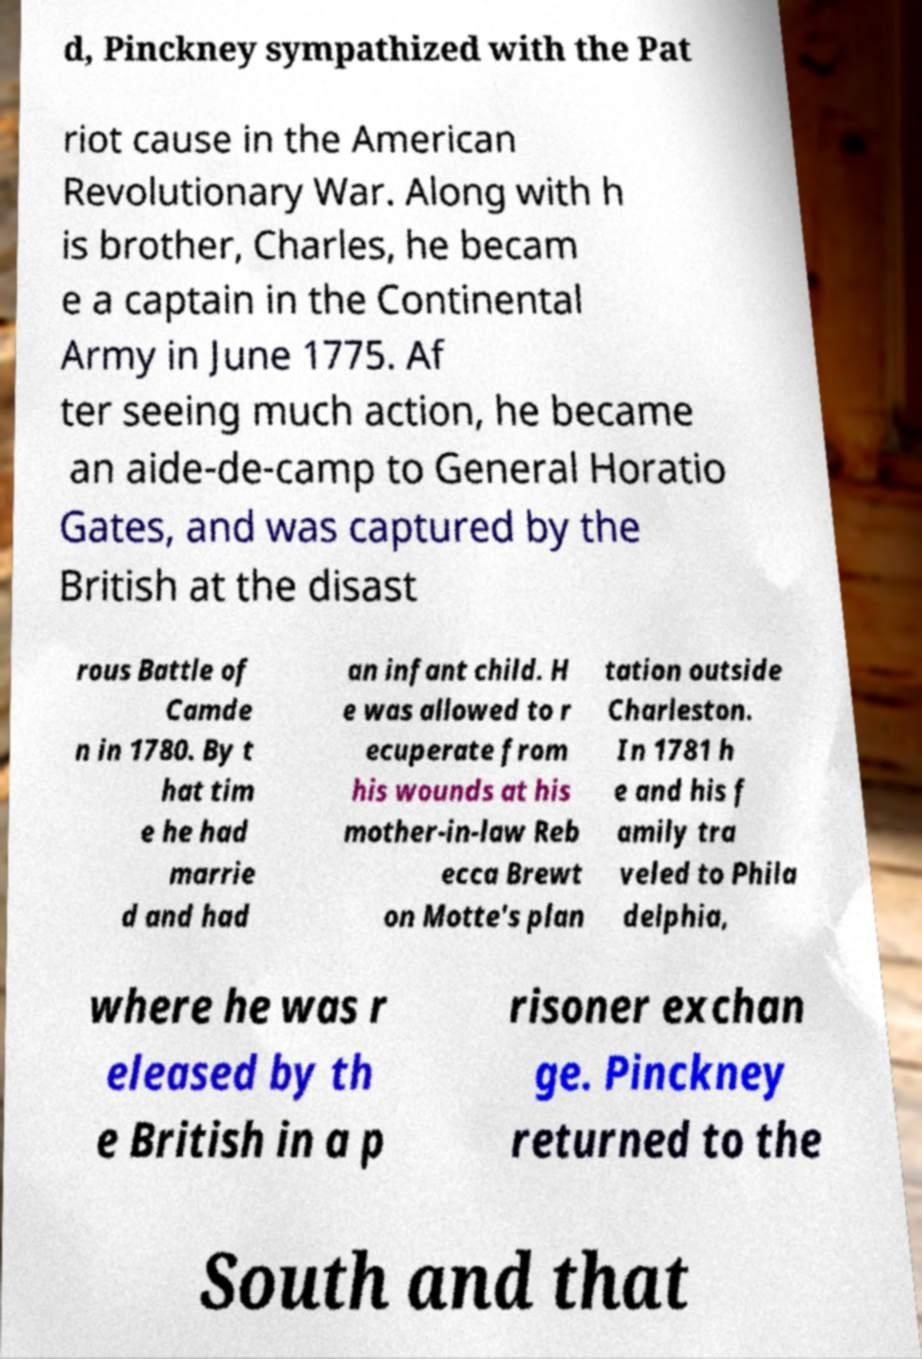Could you assist in decoding the text presented in this image and type it out clearly? d, Pinckney sympathized with the Pat riot cause in the American Revolutionary War. Along with h is brother, Charles, he becam e a captain in the Continental Army in June 1775. Af ter seeing much action, he became an aide-de-camp to General Horatio Gates, and was captured by the British at the disast rous Battle of Camde n in 1780. By t hat tim e he had marrie d and had an infant child. H e was allowed to r ecuperate from his wounds at his mother-in-law Reb ecca Brewt on Motte's plan tation outside Charleston. In 1781 h e and his f amily tra veled to Phila delphia, where he was r eleased by th e British in a p risoner exchan ge. Pinckney returned to the South and that 